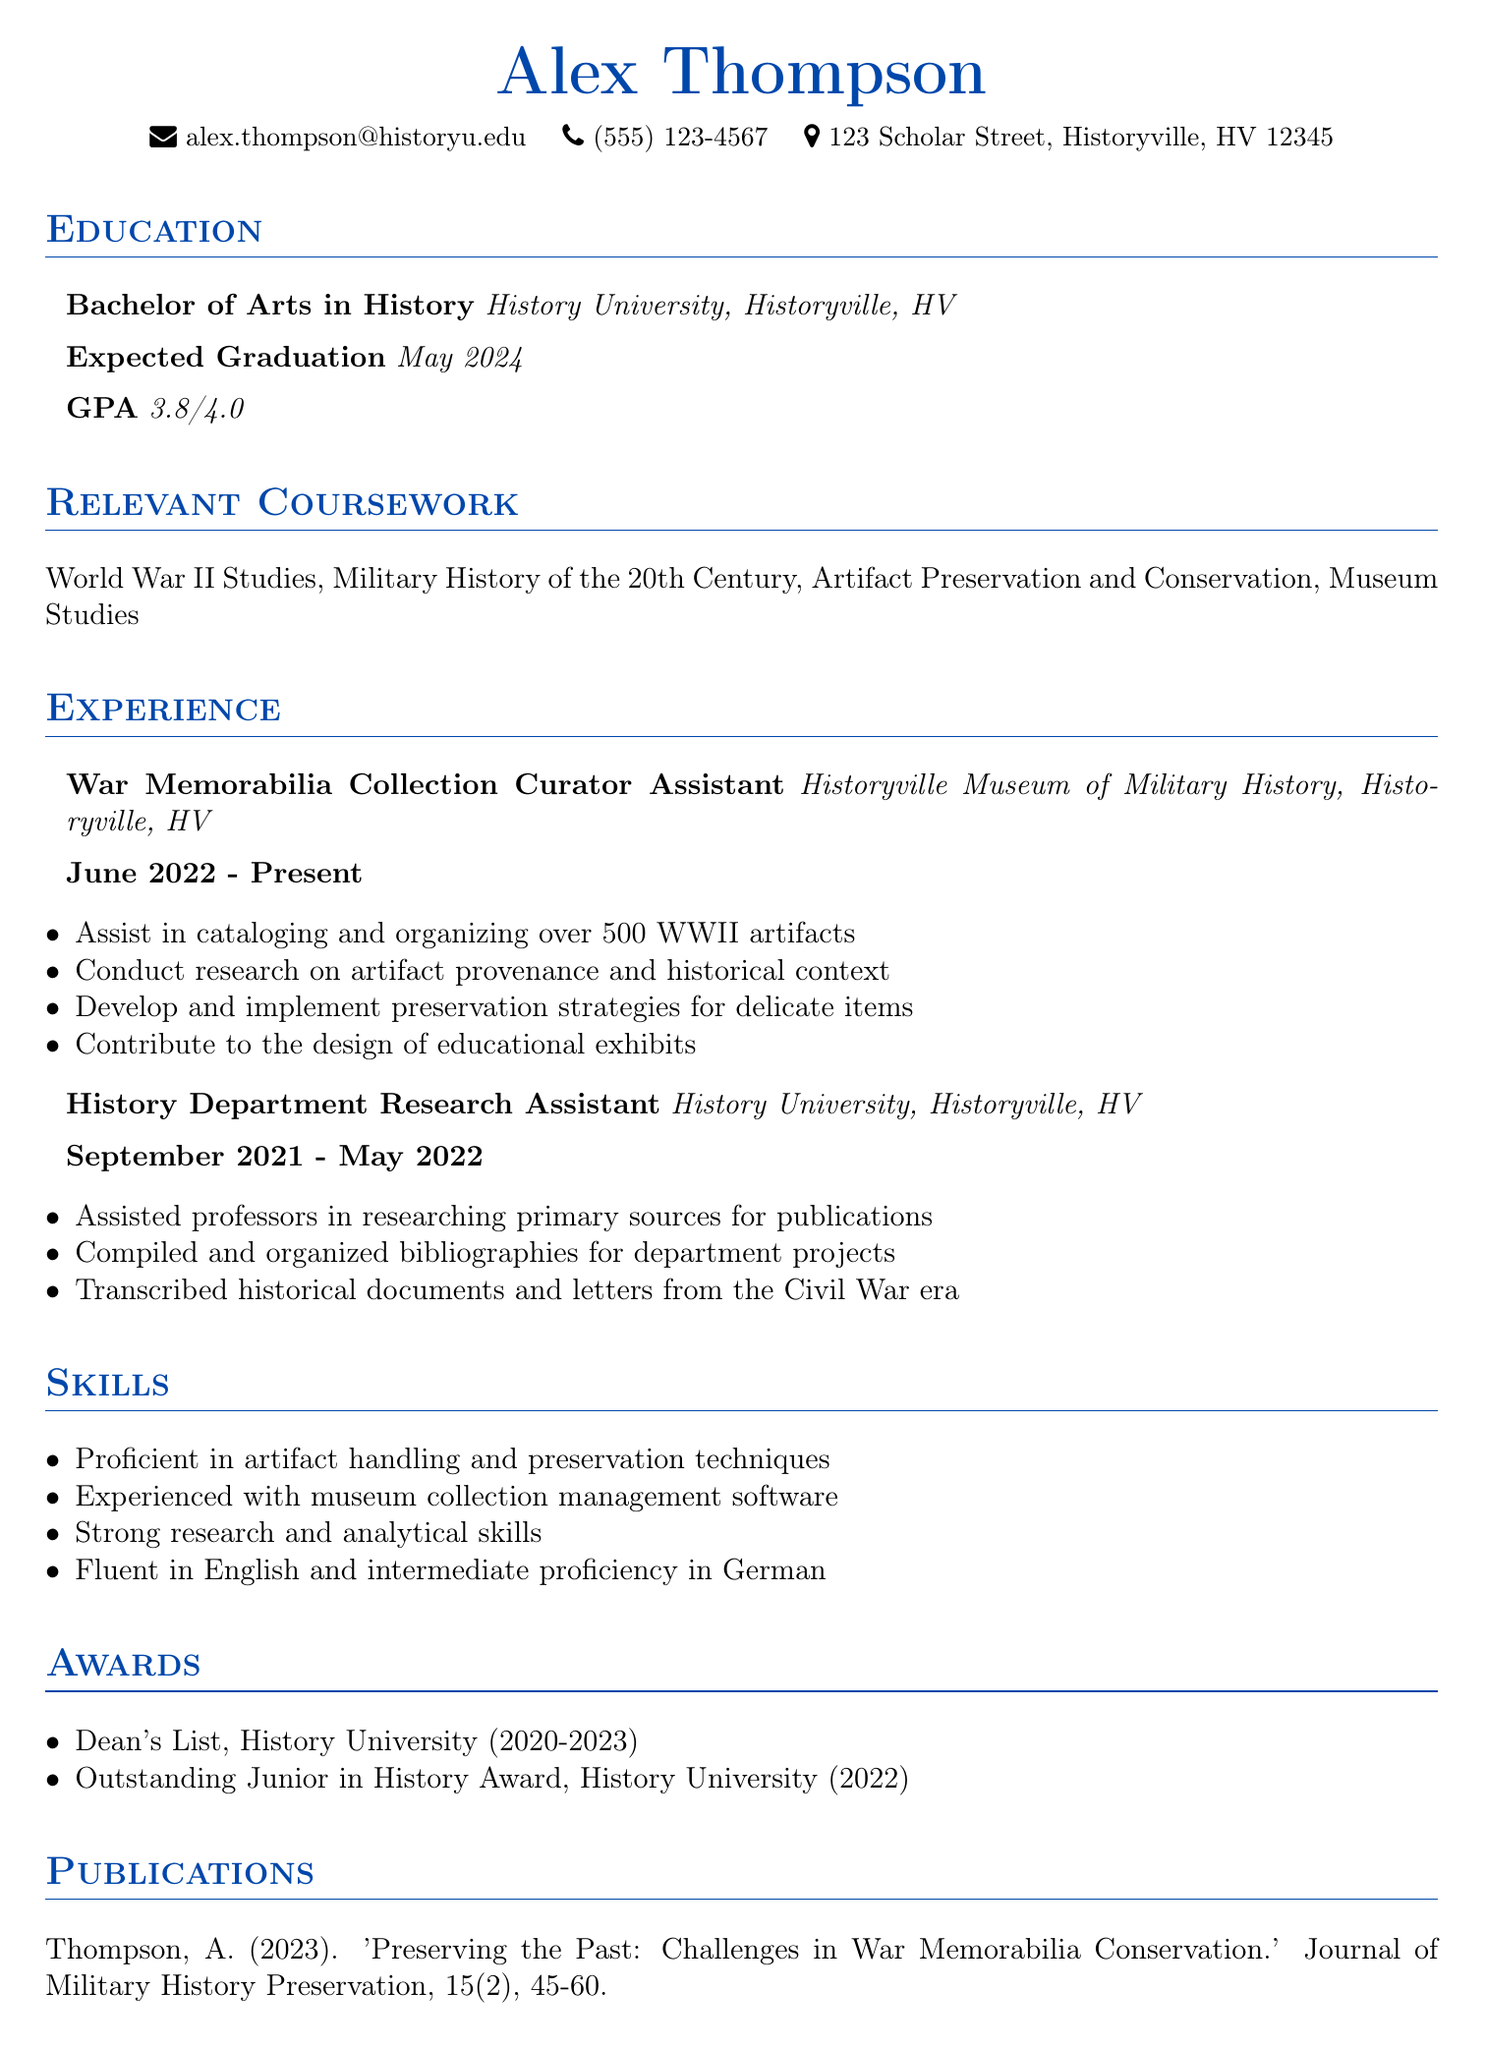What is the expected graduation date? The expected graduation date is stated in the education section of the document.
Answer: May 2024 What is the GPA of the candidate? The GPA is specified in the education section of the document.
Answer: 3.8/4.0 Which position did Alex Thompson hold from June 2022 to present? The document provides the title of the position along with the corresponding dates in the experience section.
Answer: War Memorabilia Collection Curator Assistant How many WWII artifacts has Alex cataloged and organized? The number of artifacts is mentioned in the responsibilities of the relevant experience section.
Answer: over 500 What award did Alex Thompson receive in 2022? The specific award is listed under the awards section.
Answer: Outstanding Junior in History Award What skill indicates Alex’s language proficiency? The skills section contains details about language skills, requiring synthesis of that information.
Answer: intermediate proficiency in German Which university is mentioned in the document? The name of the university appears in the education and experience sections multiple times.
Answer: History University What type of publication did Alex write in 2023? The type of publication is categorized in the publications section of the document.
Answer: Journal article 